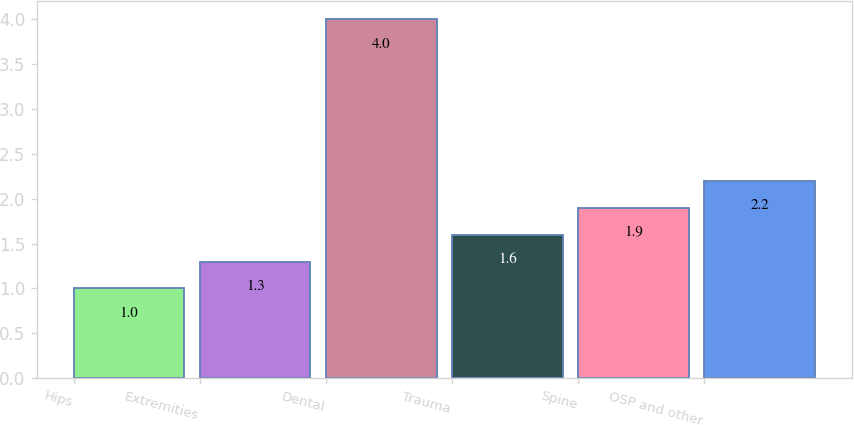Convert chart to OTSL. <chart><loc_0><loc_0><loc_500><loc_500><bar_chart><fcel>Hips<fcel>Extremities<fcel>Dental<fcel>Trauma<fcel>Spine<fcel>OSP and other<nl><fcel>1<fcel>1.3<fcel>4<fcel>1.6<fcel>1.9<fcel>2.2<nl></chart> 